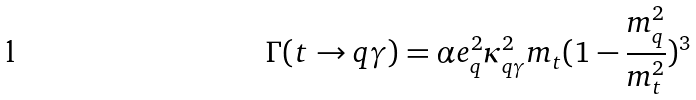<formula> <loc_0><loc_0><loc_500><loc_500>\Gamma ( t \rightarrow q \gamma ) = \alpha e _ { q } ^ { 2 } \kappa _ { q \gamma } ^ { 2 } m _ { t } ( 1 - \frac { m _ { q } ^ { 2 } } { m _ { t } ^ { 2 } } ) ^ { 3 }</formula> 